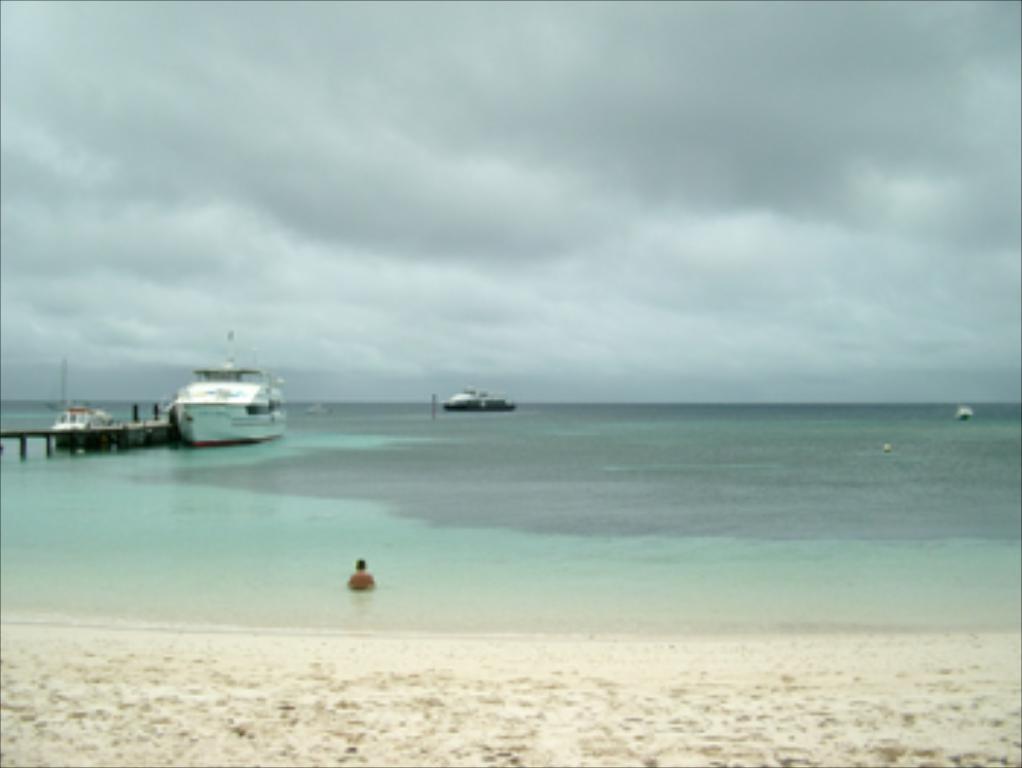In one or two sentences, can you explain what this image depicts? Here we can see water, boats and person. Sky is cloudy. 